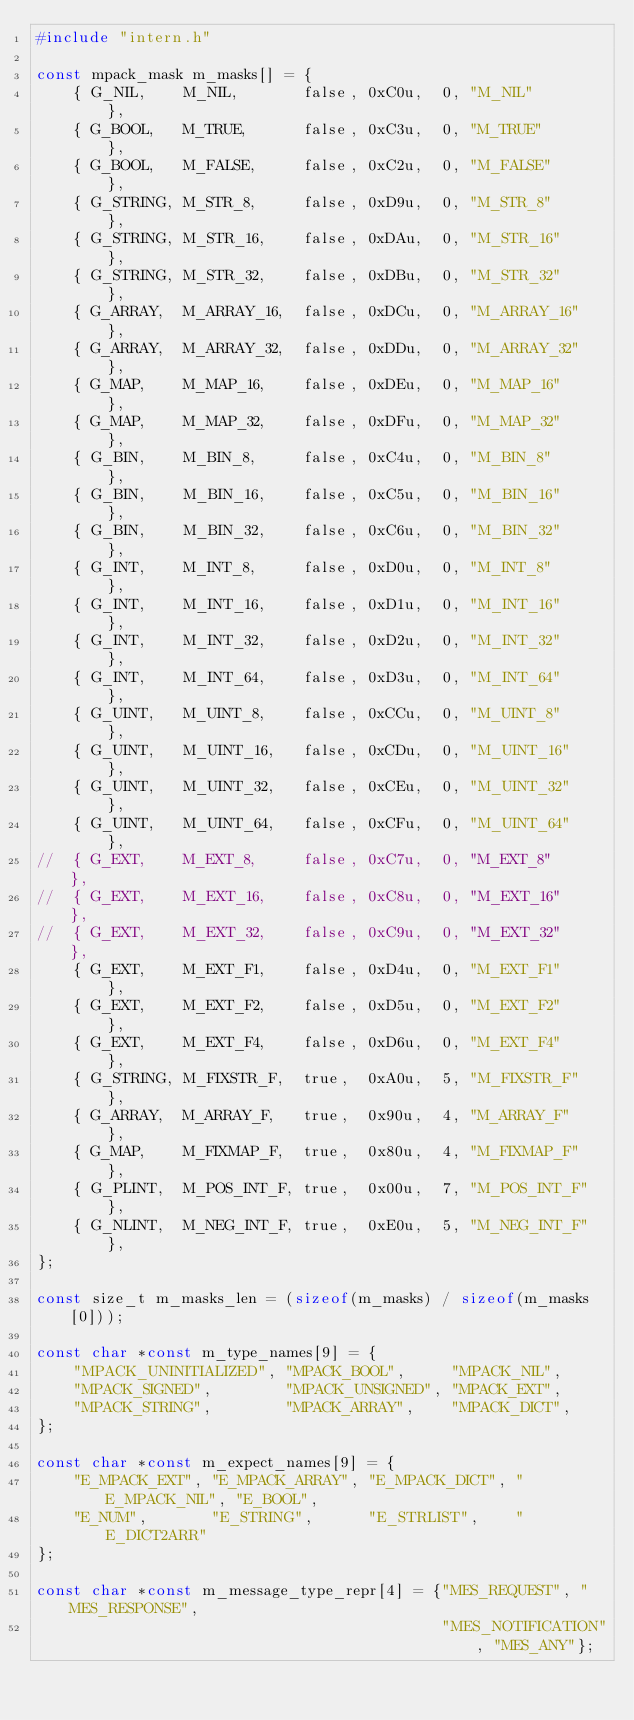Convert code to text. <code><loc_0><loc_0><loc_500><loc_500><_C_>#include "intern.h"

const mpack_mask m_masks[] = {
    { G_NIL,    M_NIL,       false, 0xC0u,  0, "M_NIL"       },
    { G_BOOL,   M_TRUE,      false, 0xC3u,  0, "M_TRUE"      },
    { G_BOOL,   M_FALSE,     false, 0xC2u,  0, "M_FALSE"     },
    { G_STRING, M_STR_8,     false, 0xD9u,  0, "M_STR_8"     },
    { G_STRING, M_STR_16,    false, 0xDAu,  0, "M_STR_16"    },
    { G_STRING, M_STR_32,    false, 0xDBu,  0, "M_STR_32"    },
    { G_ARRAY,  M_ARRAY_16,  false, 0xDCu,  0, "M_ARRAY_16"  },
    { G_ARRAY,  M_ARRAY_32,  false, 0xDDu,  0, "M_ARRAY_32"  },
    { G_MAP,    M_MAP_16,    false, 0xDEu,  0, "M_MAP_16"    },
    { G_MAP,    M_MAP_32,    false, 0xDFu,  0, "M_MAP_32"    },
    { G_BIN,    M_BIN_8,     false, 0xC4u,  0, "M_BIN_8"     },
    { G_BIN,    M_BIN_16,    false, 0xC5u,  0, "M_BIN_16"    },
    { G_BIN,    M_BIN_32,    false, 0xC6u,  0, "M_BIN_32"    },
    { G_INT,    M_INT_8,     false, 0xD0u,  0, "M_INT_8"     },
    { G_INT,    M_INT_16,    false, 0xD1u,  0, "M_INT_16"    },
    { G_INT,    M_INT_32,    false, 0xD2u,  0, "M_INT_32"    },
    { G_INT,    M_INT_64,    false, 0xD3u,  0, "M_INT_64"    },
    { G_UINT,   M_UINT_8,    false, 0xCCu,  0, "M_UINT_8"    },
    { G_UINT,   M_UINT_16,   false, 0xCDu,  0, "M_UINT_16"   },
    { G_UINT,   M_UINT_32,   false, 0xCEu,  0, "M_UINT_32"   },
    { G_UINT,   M_UINT_64,   false, 0xCFu,  0, "M_UINT_64"   },
//  { G_EXT,    M_EXT_8,     false, 0xC7u,  0, "M_EXT_8"     },
//  { G_EXT,    M_EXT_16,    false, 0xC8u,  0, "M_EXT_16"    },
//  { G_EXT,    M_EXT_32,    false, 0xC9u,  0, "M_EXT_32"    },
    { G_EXT,    M_EXT_F1,    false, 0xD4u,  0, "M_EXT_F1"    },
    { G_EXT,    M_EXT_F2,    false, 0xD5u,  0, "M_EXT_F2"    },
    { G_EXT,    M_EXT_F4,    false, 0xD6u,  0, "M_EXT_F4"    },
    { G_STRING, M_FIXSTR_F,  true,  0xA0u,  5, "M_FIXSTR_F"  },
    { G_ARRAY,  M_ARRAY_F,   true,  0x90u,  4, "M_ARRAY_F"   },
    { G_MAP,    M_FIXMAP_F,  true,  0x80u,  4, "M_FIXMAP_F"  },
    { G_PLINT,  M_POS_INT_F, true,  0x00u,  7, "M_POS_INT_F" },
    { G_NLINT,  M_NEG_INT_F, true,  0xE0u,  5, "M_NEG_INT_F" },
};

const size_t m_masks_len = (sizeof(m_masks) / sizeof(m_masks[0]));

const char *const m_type_names[9] = {
    "MPACK_UNINITIALIZED", "MPACK_BOOL",     "MPACK_NIL",
    "MPACK_SIGNED",        "MPACK_UNSIGNED", "MPACK_EXT",
    "MPACK_STRING",        "MPACK_ARRAY",    "MPACK_DICT",
};

const char *const m_expect_names[9] = {
    "E_MPACK_EXT", "E_MPACK_ARRAY", "E_MPACK_DICT", "E_MPACK_NIL", "E_BOOL",
    "E_NUM",       "E_STRING",      "E_STRLIST",    "E_DICT2ARR"
};

const char *const m_message_type_repr[4] = {"MES_REQUEST", "MES_RESPONSE",
                                            "MES_NOTIFICATION", "MES_ANY"};
</code> 